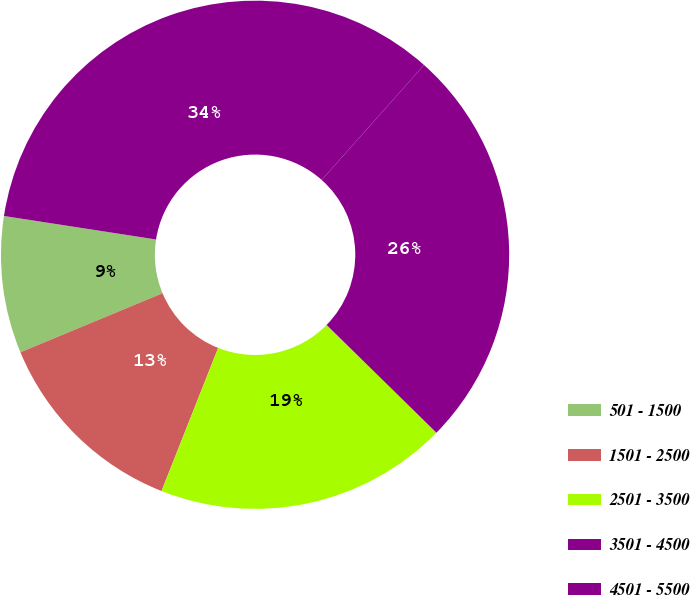Convert chart to OTSL. <chart><loc_0><loc_0><loc_500><loc_500><pie_chart><fcel>501 - 1500<fcel>1501 - 2500<fcel>2501 - 3500<fcel>3501 - 4500<fcel>4501 - 5500<nl><fcel>8.71%<fcel>12.73%<fcel>18.65%<fcel>25.77%<fcel>34.14%<nl></chart> 